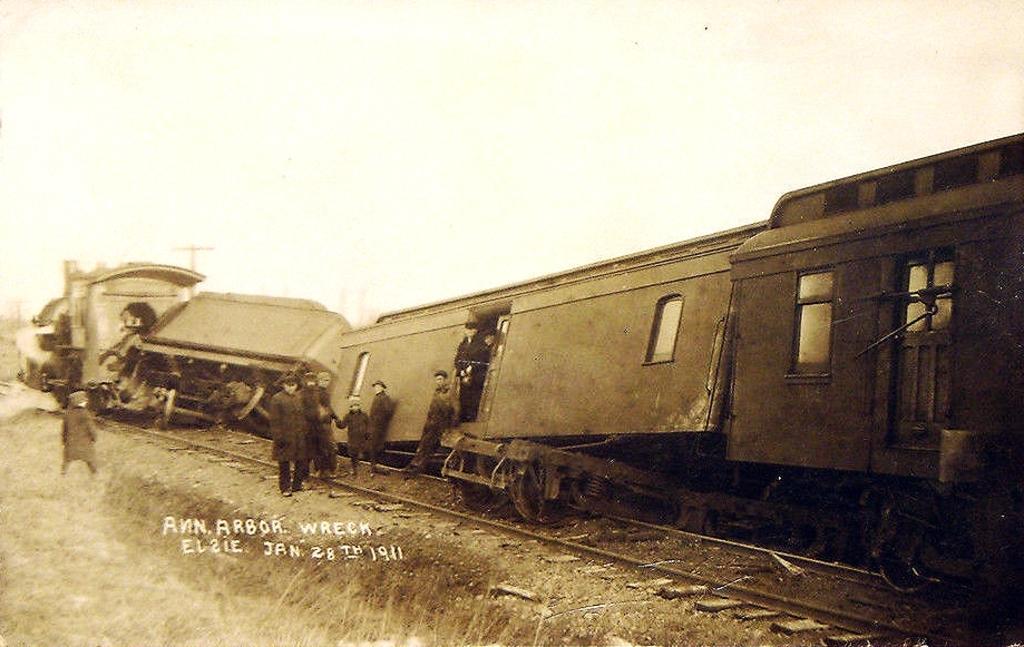Can you describe this image briefly? In the foreground of this image, there is a train which is not on the correct path and there are persons outside the train and in the background, we see poles and the sky. 